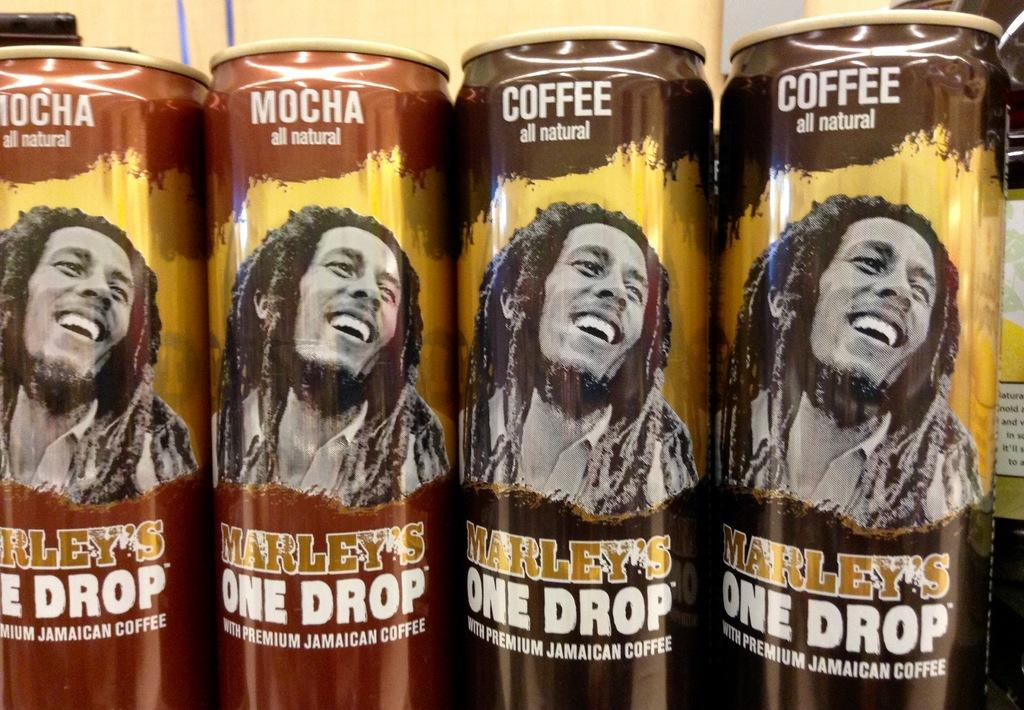<image>
Provide a brief description of the given image. close ups of several cans of Marley's One Drop coffee 